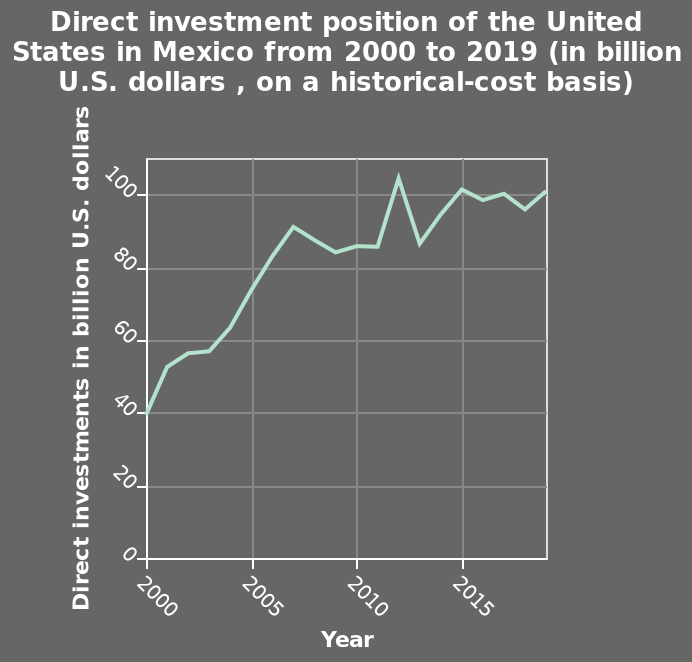<image>
When did the increase in direct investment start? The increase in direct investment started in 2000. Describe the following image in detail Here a line chart is labeled Direct investment position of the United States in Mexico from 2000 to 2019 (in billion U.S. dollars , on a historical-cost basis). The x-axis plots Year along linear scale from 2000 to 2015 while the y-axis shows Direct investments in billion U.S. dollars with linear scale of range 0 to 100. 